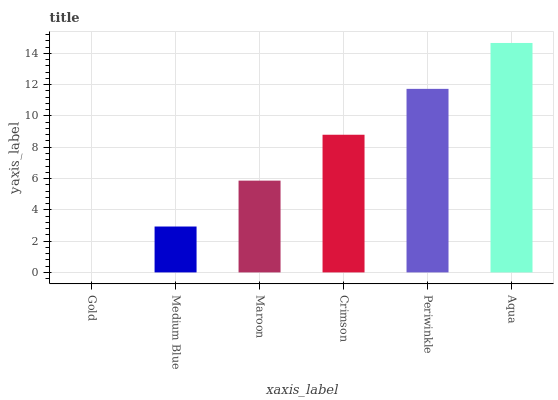Is Gold the minimum?
Answer yes or no. Yes. Is Aqua the maximum?
Answer yes or no. Yes. Is Medium Blue the minimum?
Answer yes or no. No. Is Medium Blue the maximum?
Answer yes or no. No. Is Medium Blue greater than Gold?
Answer yes or no. Yes. Is Gold less than Medium Blue?
Answer yes or no. Yes. Is Gold greater than Medium Blue?
Answer yes or no. No. Is Medium Blue less than Gold?
Answer yes or no. No. Is Crimson the high median?
Answer yes or no. Yes. Is Maroon the low median?
Answer yes or no. Yes. Is Aqua the high median?
Answer yes or no. No. Is Crimson the low median?
Answer yes or no. No. 